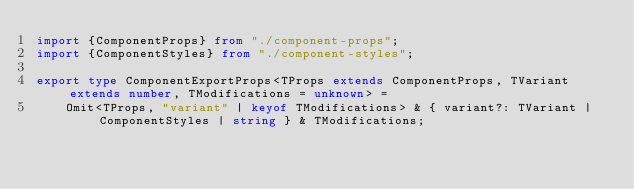Convert code to text. <code><loc_0><loc_0><loc_500><loc_500><_TypeScript_>import {ComponentProps} from "./component-props";
import {ComponentStyles} from "./component-styles";

export type ComponentExportProps<TProps extends ComponentProps, TVariant extends number, TModifications = unknown> =
    Omit<TProps, "variant" | keyof TModifications> & { variant?: TVariant | ComponentStyles | string } & TModifications;
</code> 